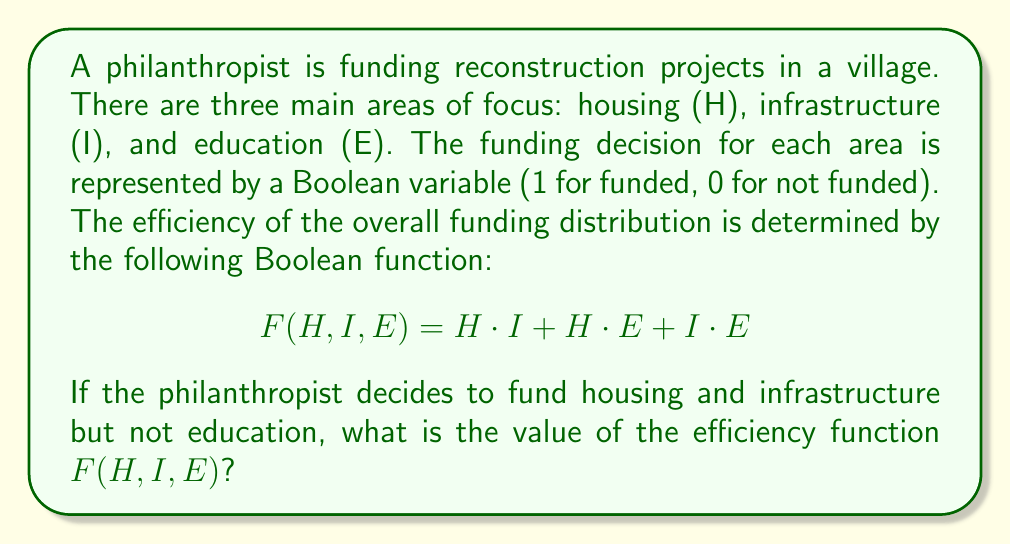Show me your answer to this math problem. Let's approach this step-by-step:

1) We are given that housing (H) and infrastructure (I) are funded, but education (E) is not. This means:
   $H = 1$
   $I = 1$
   $E = 0$

2) The efficiency function is:
   $$F(H,I,E) = H \cdot I + H \cdot E + I \cdot E$$

3) Let's substitute the values:
   $$F(1,1,0) = 1 \cdot 1 + 1 \cdot 0 + 1 \cdot 0$$

4) Now, let's evaluate each term:
   - $1 \cdot 1 = 1$
   - $1 \cdot 0 = 0$
   - $1 \cdot 0 = 0$

5) So, our function becomes:
   $$F(1,1,0) = 1 + 0 + 0$$

6) In Boolean algebra, 1 + 0 = 1, so:
   $$F(1,1,0) = 1$$

Therefore, the value of the efficiency function is 1.
Answer: 1 